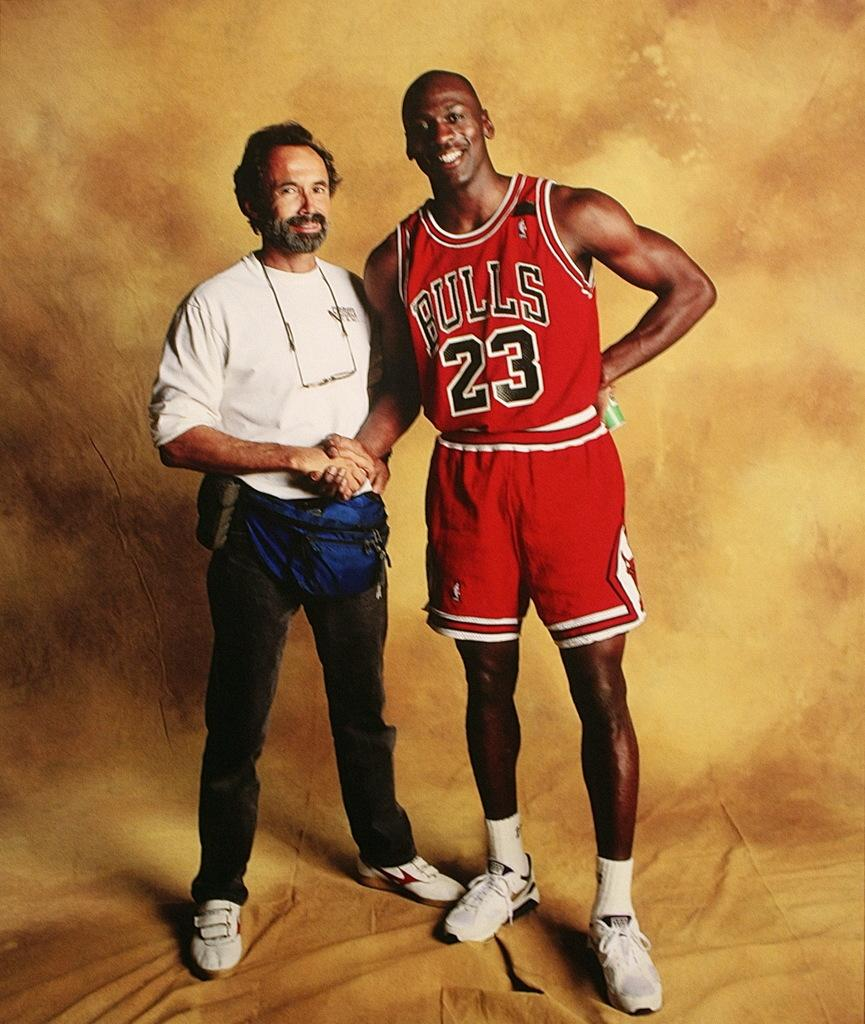How many people are in the image? There are two men in the image. What are the men doing in the image? The men are standing and shaking hands. What is the facial expression of the men in the image? The men are smiling in the image. What is present at the bottom of the image? There is a cloth at the bottom of the image. Can you see a tiger running in the image? No, there is no tiger or any running activity present in the image. 